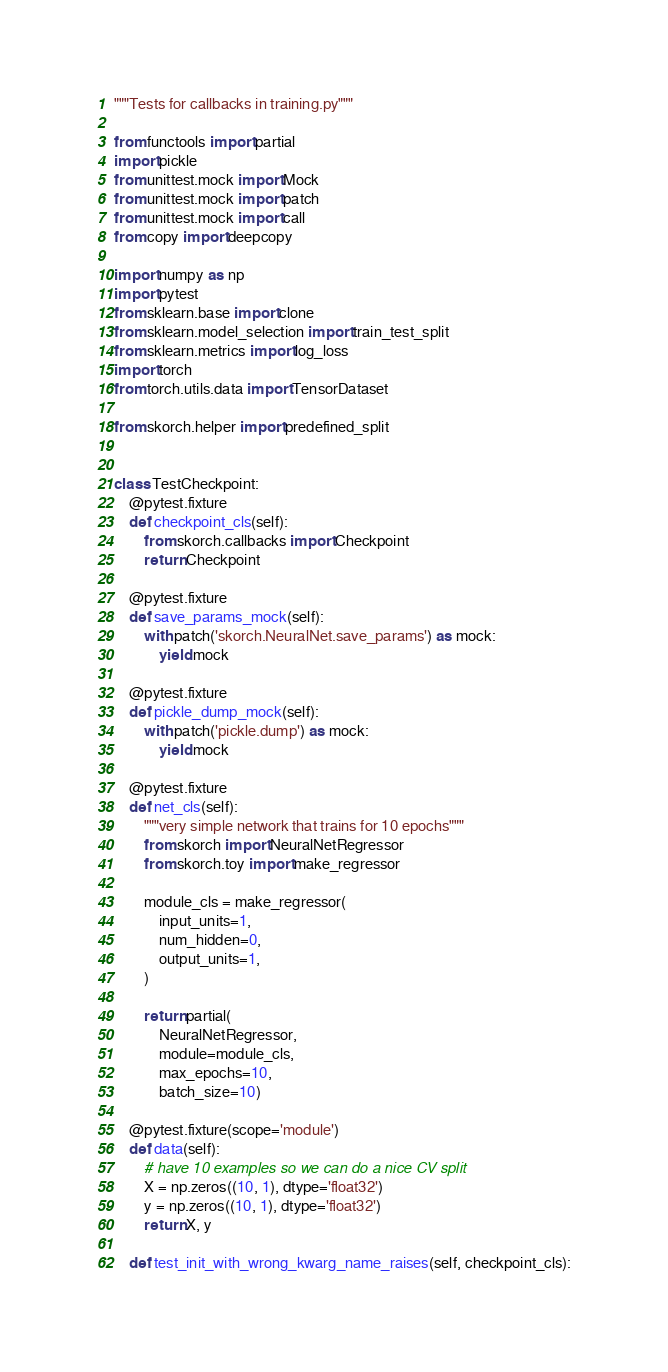<code> <loc_0><loc_0><loc_500><loc_500><_Python_>"""Tests for callbacks in training.py"""

from functools import partial
import pickle
from unittest.mock import Mock
from unittest.mock import patch
from unittest.mock import call
from copy import deepcopy

import numpy as np
import pytest
from sklearn.base import clone
from sklearn.model_selection import train_test_split
from sklearn.metrics import log_loss
import torch
from torch.utils.data import TensorDataset

from skorch.helper import predefined_split


class TestCheckpoint:
    @pytest.fixture
    def checkpoint_cls(self):
        from skorch.callbacks import Checkpoint
        return Checkpoint

    @pytest.fixture
    def save_params_mock(self):
        with patch('skorch.NeuralNet.save_params') as mock:
            yield mock

    @pytest.fixture
    def pickle_dump_mock(self):
        with patch('pickle.dump') as mock:
            yield mock

    @pytest.fixture
    def net_cls(self):
        """very simple network that trains for 10 epochs"""
        from skorch import NeuralNetRegressor
        from skorch.toy import make_regressor

        module_cls = make_regressor(
            input_units=1,
            num_hidden=0,
            output_units=1,
        )

        return partial(
            NeuralNetRegressor,
            module=module_cls,
            max_epochs=10,
            batch_size=10)

    @pytest.fixture(scope='module')
    def data(self):
        # have 10 examples so we can do a nice CV split
        X = np.zeros((10, 1), dtype='float32')
        y = np.zeros((10, 1), dtype='float32')
        return X, y

    def test_init_with_wrong_kwarg_name_raises(self, checkpoint_cls):</code> 